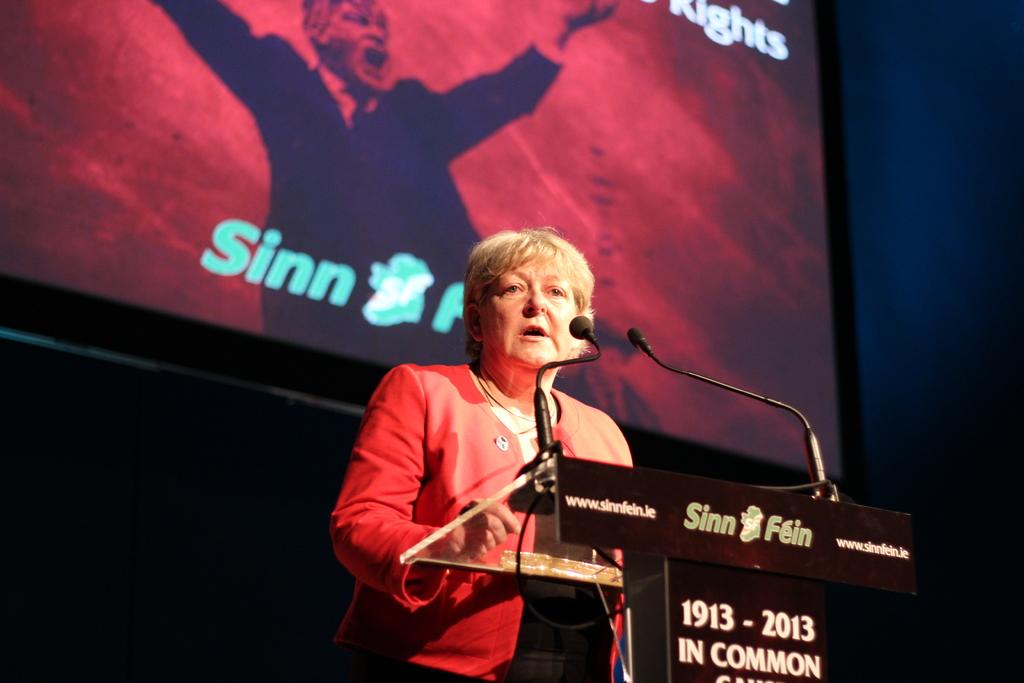What number comes after the brand name?
Keep it short and to the point. Unanswerable. 